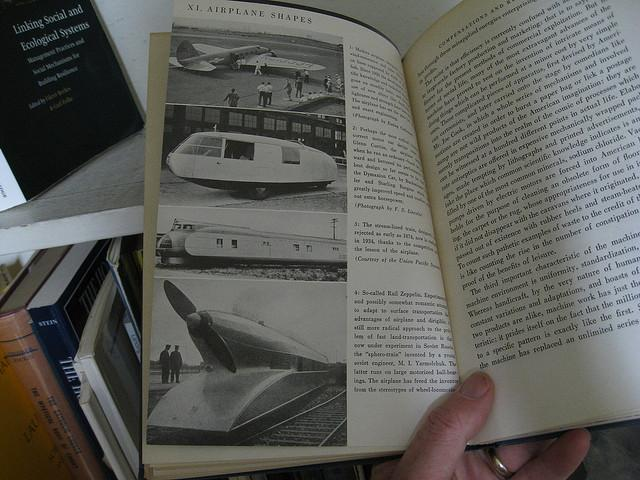What kind of object is to the front of this strange train?

Choices:
A) smokestack
B) propeller
C) face
D) engine propeller 